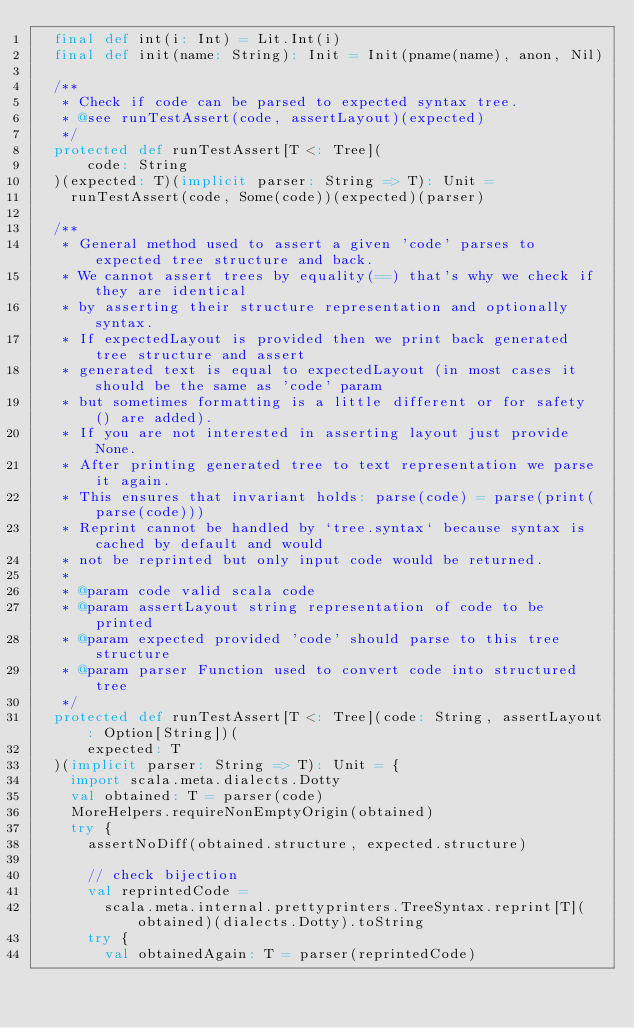<code> <loc_0><loc_0><loc_500><loc_500><_Scala_>  final def int(i: Int) = Lit.Int(i)
  final def init(name: String): Init = Init(pname(name), anon, Nil)

  /**
   * Check if code can be parsed to expected syntax tree.
   * @see runTestAssert(code, assertLayout)(expected)
   */
  protected def runTestAssert[T <: Tree](
      code: String
  )(expected: T)(implicit parser: String => T): Unit =
    runTestAssert(code, Some(code))(expected)(parser)

  /**
   * General method used to assert a given 'code' parses to expected tree structure and back.
   * We cannot assert trees by equality(==) that's why we check if they are identical
   * by asserting their structure representation and optionally syntax.
   * If expectedLayout is provided then we print back generated tree structure and assert
   * generated text is equal to expectedLayout (in most cases it should be the same as 'code' param
   * but sometimes formatting is a little different or for safety () are added).
   * If you are not interested in asserting layout just provide None.
   * After printing generated tree to text representation we parse it again.
   * This ensures that invariant holds: parse(code) = parse(print(parse(code)))
   * Reprint cannot be handled by `tree.syntax` because syntax is cached by default and would
   * not be reprinted but only input code would be returned.
   *
   * @param code valid scala code
   * @param assertLayout string representation of code to be printed
   * @param expected provided 'code' should parse to this tree structure
   * @param parser Function used to convert code into structured tree
   */
  protected def runTestAssert[T <: Tree](code: String, assertLayout: Option[String])(
      expected: T
  )(implicit parser: String => T): Unit = {
    import scala.meta.dialects.Dotty
    val obtained: T = parser(code)
    MoreHelpers.requireNonEmptyOrigin(obtained)
    try {
      assertNoDiff(obtained.structure, expected.structure)

      // check bijection
      val reprintedCode =
        scala.meta.internal.prettyprinters.TreeSyntax.reprint[T](obtained)(dialects.Dotty).toString
      try {
        val obtainedAgain: T = parser(reprintedCode)</code> 